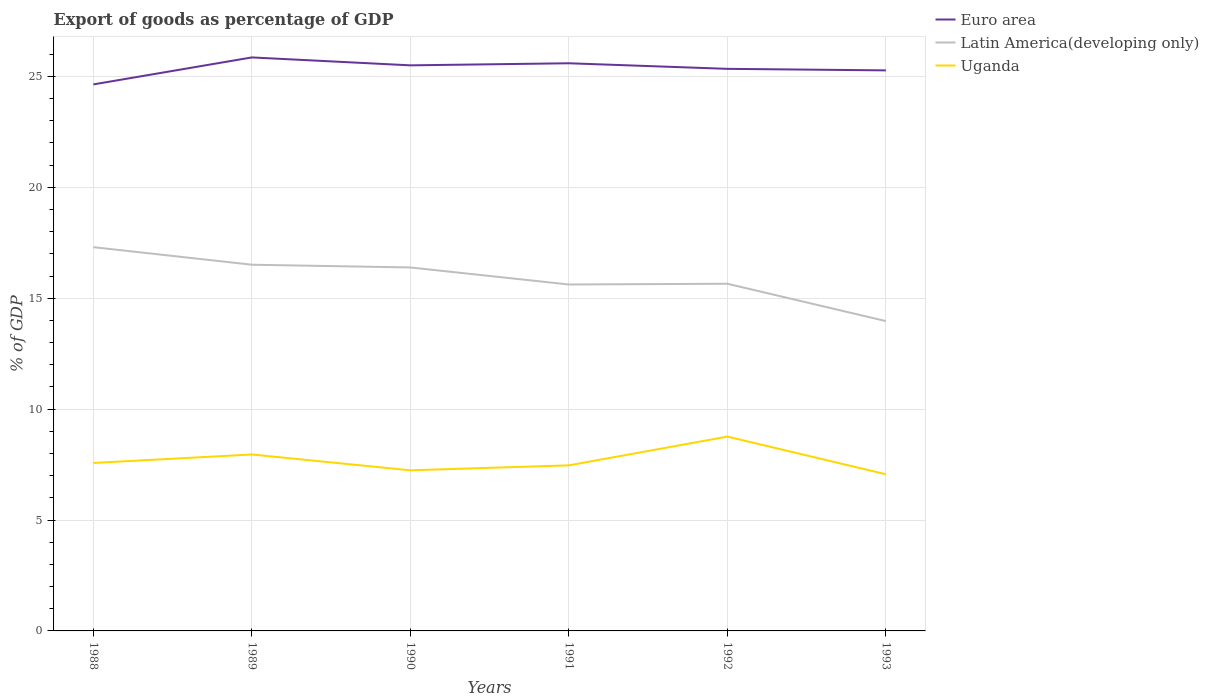How many different coloured lines are there?
Your answer should be very brief. 3. Is the number of lines equal to the number of legend labels?
Offer a terse response. Yes. Across all years, what is the maximum export of goods as percentage of GDP in Latin America(developing only)?
Provide a short and direct response. 13.97. What is the total export of goods as percentage of GDP in Uganda in the graph?
Your answer should be compact. 0.33. What is the difference between the highest and the second highest export of goods as percentage of GDP in Uganda?
Your response must be concise. 1.7. What is the difference between the highest and the lowest export of goods as percentage of GDP in Latin America(developing only)?
Your response must be concise. 3. How many years are there in the graph?
Provide a short and direct response. 6. Are the values on the major ticks of Y-axis written in scientific E-notation?
Provide a short and direct response. No. Does the graph contain any zero values?
Your answer should be compact. No. Where does the legend appear in the graph?
Keep it short and to the point. Top right. How are the legend labels stacked?
Offer a terse response. Vertical. What is the title of the graph?
Make the answer very short. Export of goods as percentage of GDP. Does "South Asia" appear as one of the legend labels in the graph?
Ensure brevity in your answer.  No. What is the label or title of the Y-axis?
Offer a very short reply. % of GDP. What is the % of GDP in Euro area in 1988?
Make the answer very short. 24.64. What is the % of GDP of Latin America(developing only) in 1988?
Provide a succinct answer. 17.3. What is the % of GDP in Uganda in 1988?
Your answer should be compact. 7.57. What is the % of GDP in Euro area in 1989?
Provide a short and direct response. 25.85. What is the % of GDP in Latin America(developing only) in 1989?
Ensure brevity in your answer.  16.51. What is the % of GDP of Uganda in 1989?
Ensure brevity in your answer.  7.95. What is the % of GDP of Euro area in 1990?
Make the answer very short. 25.5. What is the % of GDP in Latin America(developing only) in 1990?
Provide a succinct answer. 16.39. What is the % of GDP in Uganda in 1990?
Give a very brief answer. 7.24. What is the % of GDP of Euro area in 1991?
Your answer should be compact. 25.59. What is the % of GDP in Latin America(developing only) in 1991?
Your answer should be compact. 15.62. What is the % of GDP of Uganda in 1991?
Your answer should be very brief. 7.46. What is the % of GDP in Euro area in 1992?
Provide a short and direct response. 25.34. What is the % of GDP of Latin America(developing only) in 1992?
Keep it short and to the point. 15.65. What is the % of GDP of Uganda in 1992?
Provide a short and direct response. 8.76. What is the % of GDP of Euro area in 1993?
Keep it short and to the point. 25.27. What is the % of GDP in Latin America(developing only) in 1993?
Give a very brief answer. 13.97. What is the % of GDP of Uganda in 1993?
Your response must be concise. 7.06. Across all years, what is the maximum % of GDP of Euro area?
Your answer should be compact. 25.85. Across all years, what is the maximum % of GDP of Latin America(developing only)?
Your response must be concise. 17.3. Across all years, what is the maximum % of GDP of Uganda?
Give a very brief answer. 8.76. Across all years, what is the minimum % of GDP of Euro area?
Provide a succinct answer. 24.64. Across all years, what is the minimum % of GDP in Latin America(developing only)?
Ensure brevity in your answer.  13.97. Across all years, what is the minimum % of GDP of Uganda?
Give a very brief answer. 7.06. What is the total % of GDP in Euro area in the graph?
Offer a terse response. 152.19. What is the total % of GDP in Latin America(developing only) in the graph?
Provide a succinct answer. 95.43. What is the total % of GDP of Uganda in the graph?
Provide a succinct answer. 46.06. What is the difference between the % of GDP in Euro area in 1988 and that in 1989?
Provide a succinct answer. -1.22. What is the difference between the % of GDP in Latin America(developing only) in 1988 and that in 1989?
Offer a very short reply. 0.79. What is the difference between the % of GDP in Uganda in 1988 and that in 1989?
Offer a terse response. -0.38. What is the difference between the % of GDP of Euro area in 1988 and that in 1990?
Make the answer very short. -0.86. What is the difference between the % of GDP in Latin America(developing only) in 1988 and that in 1990?
Keep it short and to the point. 0.91. What is the difference between the % of GDP in Uganda in 1988 and that in 1990?
Give a very brief answer. 0.33. What is the difference between the % of GDP in Euro area in 1988 and that in 1991?
Your answer should be compact. -0.95. What is the difference between the % of GDP of Latin America(developing only) in 1988 and that in 1991?
Give a very brief answer. 1.68. What is the difference between the % of GDP in Uganda in 1988 and that in 1991?
Provide a short and direct response. 0.11. What is the difference between the % of GDP in Euro area in 1988 and that in 1992?
Ensure brevity in your answer.  -0.7. What is the difference between the % of GDP in Latin America(developing only) in 1988 and that in 1992?
Give a very brief answer. 1.65. What is the difference between the % of GDP of Uganda in 1988 and that in 1992?
Keep it short and to the point. -1.19. What is the difference between the % of GDP of Euro area in 1988 and that in 1993?
Offer a very short reply. -0.63. What is the difference between the % of GDP of Latin America(developing only) in 1988 and that in 1993?
Your response must be concise. 3.33. What is the difference between the % of GDP of Uganda in 1988 and that in 1993?
Offer a terse response. 0.51. What is the difference between the % of GDP of Euro area in 1989 and that in 1990?
Your answer should be compact. 0.36. What is the difference between the % of GDP in Latin America(developing only) in 1989 and that in 1990?
Provide a succinct answer. 0.12. What is the difference between the % of GDP of Uganda in 1989 and that in 1990?
Provide a succinct answer. 0.71. What is the difference between the % of GDP of Euro area in 1989 and that in 1991?
Give a very brief answer. 0.26. What is the difference between the % of GDP of Latin America(developing only) in 1989 and that in 1991?
Your response must be concise. 0.89. What is the difference between the % of GDP in Uganda in 1989 and that in 1991?
Ensure brevity in your answer.  0.49. What is the difference between the % of GDP of Euro area in 1989 and that in 1992?
Ensure brevity in your answer.  0.51. What is the difference between the % of GDP of Latin America(developing only) in 1989 and that in 1992?
Make the answer very short. 0.86. What is the difference between the % of GDP of Uganda in 1989 and that in 1992?
Your response must be concise. -0.81. What is the difference between the % of GDP of Euro area in 1989 and that in 1993?
Ensure brevity in your answer.  0.58. What is the difference between the % of GDP of Latin America(developing only) in 1989 and that in 1993?
Your answer should be very brief. 2.54. What is the difference between the % of GDP of Uganda in 1989 and that in 1993?
Your response must be concise. 0.89. What is the difference between the % of GDP of Euro area in 1990 and that in 1991?
Make the answer very short. -0.09. What is the difference between the % of GDP of Latin America(developing only) in 1990 and that in 1991?
Make the answer very short. 0.77. What is the difference between the % of GDP in Uganda in 1990 and that in 1991?
Provide a succinct answer. -0.22. What is the difference between the % of GDP of Euro area in 1990 and that in 1992?
Make the answer very short. 0.16. What is the difference between the % of GDP of Latin America(developing only) in 1990 and that in 1992?
Offer a very short reply. 0.73. What is the difference between the % of GDP of Uganda in 1990 and that in 1992?
Your answer should be compact. -1.52. What is the difference between the % of GDP of Euro area in 1990 and that in 1993?
Ensure brevity in your answer.  0.23. What is the difference between the % of GDP of Latin America(developing only) in 1990 and that in 1993?
Your answer should be very brief. 2.42. What is the difference between the % of GDP in Uganda in 1990 and that in 1993?
Give a very brief answer. 0.18. What is the difference between the % of GDP in Euro area in 1991 and that in 1992?
Keep it short and to the point. 0.25. What is the difference between the % of GDP of Latin America(developing only) in 1991 and that in 1992?
Keep it short and to the point. -0.03. What is the difference between the % of GDP in Uganda in 1991 and that in 1992?
Offer a terse response. -1.3. What is the difference between the % of GDP in Euro area in 1991 and that in 1993?
Keep it short and to the point. 0.32. What is the difference between the % of GDP in Latin America(developing only) in 1991 and that in 1993?
Give a very brief answer. 1.65. What is the difference between the % of GDP of Uganda in 1991 and that in 1993?
Provide a short and direct response. 0.4. What is the difference between the % of GDP of Euro area in 1992 and that in 1993?
Provide a succinct answer. 0.07. What is the difference between the % of GDP of Latin America(developing only) in 1992 and that in 1993?
Your response must be concise. 1.68. What is the difference between the % of GDP in Uganda in 1992 and that in 1993?
Keep it short and to the point. 1.7. What is the difference between the % of GDP in Euro area in 1988 and the % of GDP in Latin America(developing only) in 1989?
Keep it short and to the point. 8.13. What is the difference between the % of GDP of Euro area in 1988 and the % of GDP of Uganda in 1989?
Ensure brevity in your answer.  16.68. What is the difference between the % of GDP of Latin America(developing only) in 1988 and the % of GDP of Uganda in 1989?
Offer a terse response. 9.35. What is the difference between the % of GDP of Euro area in 1988 and the % of GDP of Latin America(developing only) in 1990?
Give a very brief answer. 8.25. What is the difference between the % of GDP of Euro area in 1988 and the % of GDP of Uganda in 1990?
Give a very brief answer. 17.4. What is the difference between the % of GDP of Latin America(developing only) in 1988 and the % of GDP of Uganda in 1990?
Provide a short and direct response. 10.06. What is the difference between the % of GDP in Euro area in 1988 and the % of GDP in Latin America(developing only) in 1991?
Your answer should be very brief. 9.02. What is the difference between the % of GDP in Euro area in 1988 and the % of GDP in Uganda in 1991?
Provide a succinct answer. 17.17. What is the difference between the % of GDP in Latin America(developing only) in 1988 and the % of GDP in Uganda in 1991?
Your answer should be compact. 9.84. What is the difference between the % of GDP in Euro area in 1988 and the % of GDP in Latin America(developing only) in 1992?
Your response must be concise. 8.99. What is the difference between the % of GDP of Euro area in 1988 and the % of GDP of Uganda in 1992?
Provide a short and direct response. 15.88. What is the difference between the % of GDP of Latin America(developing only) in 1988 and the % of GDP of Uganda in 1992?
Provide a succinct answer. 8.54. What is the difference between the % of GDP in Euro area in 1988 and the % of GDP in Latin America(developing only) in 1993?
Make the answer very short. 10.67. What is the difference between the % of GDP in Euro area in 1988 and the % of GDP in Uganda in 1993?
Your answer should be compact. 17.58. What is the difference between the % of GDP in Latin America(developing only) in 1988 and the % of GDP in Uganda in 1993?
Give a very brief answer. 10.24. What is the difference between the % of GDP in Euro area in 1989 and the % of GDP in Latin America(developing only) in 1990?
Keep it short and to the point. 9.47. What is the difference between the % of GDP of Euro area in 1989 and the % of GDP of Uganda in 1990?
Your answer should be compact. 18.61. What is the difference between the % of GDP of Latin America(developing only) in 1989 and the % of GDP of Uganda in 1990?
Offer a terse response. 9.27. What is the difference between the % of GDP of Euro area in 1989 and the % of GDP of Latin America(developing only) in 1991?
Offer a very short reply. 10.24. What is the difference between the % of GDP in Euro area in 1989 and the % of GDP in Uganda in 1991?
Offer a very short reply. 18.39. What is the difference between the % of GDP of Latin America(developing only) in 1989 and the % of GDP of Uganda in 1991?
Keep it short and to the point. 9.04. What is the difference between the % of GDP in Euro area in 1989 and the % of GDP in Latin America(developing only) in 1992?
Offer a very short reply. 10.2. What is the difference between the % of GDP of Euro area in 1989 and the % of GDP of Uganda in 1992?
Give a very brief answer. 17.09. What is the difference between the % of GDP in Latin America(developing only) in 1989 and the % of GDP in Uganda in 1992?
Ensure brevity in your answer.  7.75. What is the difference between the % of GDP of Euro area in 1989 and the % of GDP of Latin America(developing only) in 1993?
Your answer should be very brief. 11.89. What is the difference between the % of GDP of Euro area in 1989 and the % of GDP of Uganda in 1993?
Give a very brief answer. 18.79. What is the difference between the % of GDP of Latin America(developing only) in 1989 and the % of GDP of Uganda in 1993?
Your answer should be very brief. 9.45. What is the difference between the % of GDP in Euro area in 1990 and the % of GDP in Latin America(developing only) in 1991?
Your response must be concise. 9.88. What is the difference between the % of GDP of Euro area in 1990 and the % of GDP of Uganda in 1991?
Your answer should be compact. 18.03. What is the difference between the % of GDP of Latin America(developing only) in 1990 and the % of GDP of Uganda in 1991?
Keep it short and to the point. 8.92. What is the difference between the % of GDP in Euro area in 1990 and the % of GDP in Latin America(developing only) in 1992?
Offer a terse response. 9.85. What is the difference between the % of GDP in Euro area in 1990 and the % of GDP in Uganda in 1992?
Ensure brevity in your answer.  16.74. What is the difference between the % of GDP of Latin America(developing only) in 1990 and the % of GDP of Uganda in 1992?
Ensure brevity in your answer.  7.62. What is the difference between the % of GDP of Euro area in 1990 and the % of GDP of Latin America(developing only) in 1993?
Ensure brevity in your answer.  11.53. What is the difference between the % of GDP of Euro area in 1990 and the % of GDP of Uganda in 1993?
Your answer should be compact. 18.44. What is the difference between the % of GDP in Latin America(developing only) in 1990 and the % of GDP in Uganda in 1993?
Provide a succinct answer. 9.32. What is the difference between the % of GDP of Euro area in 1991 and the % of GDP of Latin America(developing only) in 1992?
Your answer should be very brief. 9.94. What is the difference between the % of GDP of Euro area in 1991 and the % of GDP of Uganda in 1992?
Make the answer very short. 16.83. What is the difference between the % of GDP in Latin America(developing only) in 1991 and the % of GDP in Uganda in 1992?
Keep it short and to the point. 6.86. What is the difference between the % of GDP in Euro area in 1991 and the % of GDP in Latin America(developing only) in 1993?
Offer a very short reply. 11.62. What is the difference between the % of GDP in Euro area in 1991 and the % of GDP in Uganda in 1993?
Keep it short and to the point. 18.53. What is the difference between the % of GDP in Latin America(developing only) in 1991 and the % of GDP in Uganda in 1993?
Provide a succinct answer. 8.56. What is the difference between the % of GDP of Euro area in 1992 and the % of GDP of Latin America(developing only) in 1993?
Your response must be concise. 11.37. What is the difference between the % of GDP of Euro area in 1992 and the % of GDP of Uganda in 1993?
Offer a very short reply. 18.28. What is the difference between the % of GDP of Latin America(developing only) in 1992 and the % of GDP of Uganda in 1993?
Ensure brevity in your answer.  8.59. What is the average % of GDP in Euro area per year?
Your answer should be compact. 25.37. What is the average % of GDP in Latin America(developing only) per year?
Your response must be concise. 15.91. What is the average % of GDP of Uganda per year?
Your answer should be compact. 7.68. In the year 1988, what is the difference between the % of GDP of Euro area and % of GDP of Latin America(developing only)?
Provide a succinct answer. 7.34. In the year 1988, what is the difference between the % of GDP of Euro area and % of GDP of Uganda?
Your answer should be compact. 17.07. In the year 1988, what is the difference between the % of GDP in Latin America(developing only) and % of GDP in Uganda?
Offer a terse response. 9.73. In the year 1989, what is the difference between the % of GDP of Euro area and % of GDP of Latin America(developing only)?
Give a very brief answer. 9.35. In the year 1989, what is the difference between the % of GDP in Euro area and % of GDP in Uganda?
Keep it short and to the point. 17.9. In the year 1989, what is the difference between the % of GDP of Latin America(developing only) and % of GDP of Uganda?
Make the answer very short. 8.55. In the year 1990, what is the difference between the % of GDP in Euro area and % of GDP in Latin America(developing only)?
Offer a terse response. 9.11. In the year 1990, what is the difference between the % of GDP of Euro area and % of GDP of Uganda?
Keep it short and to the point. 18.26. In the year 1990, what is the difference between the % of GDP in Latin America(developing only) and % of GDP in Uganda?
Make the answer very short. 9.14. In the year 1991, what is the difference between the % of GDP of Euro area and % of GDP of Latin America(developing only)?
Offer a very short reply. 9.97. In the year 1991, what is the difference between the % of GDP in Euro area and % of GDP in Uganda?
Ensure brevity in your answer.  18.13. In the year 1991, what is the difference between the % of GDP in Latin America(developing only) and % of GDP in Uganda?
Ensure brevity in your answer.  8.15. In the year 1992, what is the difference between the % of GDP in Euro area and % of GDP in Latin America(developing only)?
Your response must be concise. 9.69. In the year 1992, what is the difference between the % of GDP of Euro area and % of GDP of Uganda?
Provide a succinct answer. 16.58. In the year 1992, what is the difference between the % of GDP in Latin America(developing only) and % of GDP in Uganda?
Provide a succinct answer. 6.89. In the year 1993, what is the difference between the % of GDP of Euro area and % of GDP of Latin America(developing only)?
Provide a short and direct response. 11.3. In the year 1993, what is the difference between the % of GDP of Euro area and % of GDP of Uganda?
Provide a succinct answer. 18.21. In the year 1993, what is the difference between the % of GDP in Latin America(developing only) and % of GDP in Uganda?
Offer a terse response. 6.91. What is the ratio of the % of GDP in Euro area in 1988 to that in 1989?
Ensure brevity in your answer.  0.95. What is the ratio of the % of GDP in Latin America(developing only) in 1988 to that in 1989?
Provide a succinct answer. 1.05. What is the ratio of the % of GDP of Uganda in 1988 to that in 1989?
Give a very brief answer. 0.95. What is the ratio of the % of GDP of Euro area in 1988 to that in 1990?
Your answer should be very brief. 0.97. What is the ratio of the % of GDP of Latin America(developing only) in 1988 to that in 1990?
Make the answer very short. 1.06. What is the ratio of the % of GDP in Uganda in 1988 to that in 1990?
Give a very brief answer. 1.05. What is the ratio of the % of GDP of Euro area in 1988 to that in 1991?
Offer a very short reply. 0.96. What is the ratio of the % of GDP in Latin America(developing only) in 1988 to that in 1991?
Your answer should be very brief. 1.11. What is the ratio of the % of GDP of Uganda in 1988 to that in 1991?
Ensure brevity in your answer.  1.01. What is the ratio of the % of GDP in Euro area in 1988 to that in 1992?
Offer a terse response. 0.97. What is the ratio of the % of GDP of Latin America(developing only) in 1988 to that in 1992?
Offer a very short reply. 1.11. What is the ratio of the % of GDP of Uganda in 1988 to that in 1992?
Provide a succinct answer. 0.86. What is the ratio of the % of GDP in Euro area in 1988 to that in 1993?
Provide a succinct answer. 0.97. What is the ratio of the % of GDP in Latin America(developing only) in 1988 to that in 1993?
Provide a short and direct response. 1.24. What is the ratio of the % of GDP in Uganda in 1988 to that in 1993?
Your response must be concise. 1.07. What is the ratio of the % of GDP of Latin America(developing only) in 1989 to that in 1990?
Provide a succinct answer. 1.01. What is the ratio of the % of GDP of Uganda in 1989 to that in 1990?
Your answer should be very brief. 1.1. What is the ratio of the % of GDP of Euro area in 1989 to that in 1991?
Offer a terse response. 1.01. What is the ratio of the % of GDP of Latin America(developing only) in 1989 to that in 1991?
Make the answer very short. 1.06. What is the ratio of the % of GDP of Uganda in 1989 to that in 1991?
Provide a succinct answer. 1.07. What is the ratio of the % of GDP in Euro area in 1989 to that in 1992?
Your response must be concise. 1.02. What is the ratio of the % of GDP in Latin America(developing only) in 1989 to that in 1992?
Your answer should be compact. 1.05. What is the ratio of the % of GDP in Uganda in 1989 to that in 1992?
Provide a succinct answer. 0.91. What is the ratio of the % of GDP in Euro area in 1989 to that in 1993?
Your answer should be compact. 1.02. What is the ratio of the % of GDP of Latin America(developing only) in 1989 to that in 1993?
Provide a succinct answer. 1.18. What is the ratio of the % of GDP in Uganda in 1989 to that in 1993?
Keep it short and to the point. 1.13. What is the ratio of the % of GDP in Latin America(developing only) in 1990 to that in 1991?
Keep it short and to the point. 1.05. What is the ratio of the % of GDP of Uganda in 1990 to that in 1991?
Your answer should be very brief. 0.97. What is the ratio of the % of GDP of Latin America(developing only) in 1990 to that in 1992?
Offer a very short reply. 1.05. What is the ratio of the % of GDP in Uganda in 1990 to that in 1992?
Your response must be concise. 0.83. What is the ratio of the % of GDP in Euro area in 1990 to that in 1993?
Ensure brevity in your answer.  1.01. What is the ratio of the % of GDP of Latin America(developing only) in 1990 to that in 1993?
Offer a terse response. 1.17. What is the ratio of the % of GDP in Uganda in 1990 to that in 1993?
Provide a short and direct response. 1.03. What is the ratio of the % of GDP in Euro area in 1991 to that in 1992?
Your answer should be compact. 1.01. What is the ratio of the % of GDP in Latin America(developing only) in 1991 to that in 1992?
Provide a succinct answer. 1. What is the ratio of the % of GDP in Uganda in 1991 to that in 1992?
Provide a succinct answer. 0.85. What is the ratio of the % of GDP of Euro area in 1991 to that in 1993?
Ensure brevity in your answer.  1.01. What is the ratio of the % of GDP in Latin America(developing only) in 1991 to that in 1993?
Provide a short and direct response. 1.12. What is the ratio of the % of GDP of Uganda in 1991 to that in 1993?
Your response must be concise. 1.06. What is the ratio of the % of GDP in Euro area in 1992 to that in 1993?
Ensure brevity in your answer.  1. What is the ratio of the % of GDP in Latin America(developing only) in 1992 to that in 1993?
Your answer should be compact. 1.12. What is the ratio of the % of GDP in Uganda in 1992 to that in 1993?
Ensure brevity in your answer.  1.24. What is the difference between the highest and the second highest % of GDP in Euro area?
Offer a terse response. 0.26. What is the difference between the highest and the second highest % of GDP of Latin America(developing only)?
Offer a very short reply. 0.79. What is the difference between the highest and the second highest % of GDP of Uganda?
Ensure brevity in your answer.  0.81. What is the difference between the highest and the lowest % of GDP of Euro area?
Your answer should be compact. 1.22. What is the difference between the highest and the lowest % of GDP in Latin America(developing only)?
Offer a very short reply. 3.33. What is the difference between the highest and the lowest % of GDP of Uganda?
Your response must be concise. 1.7. 